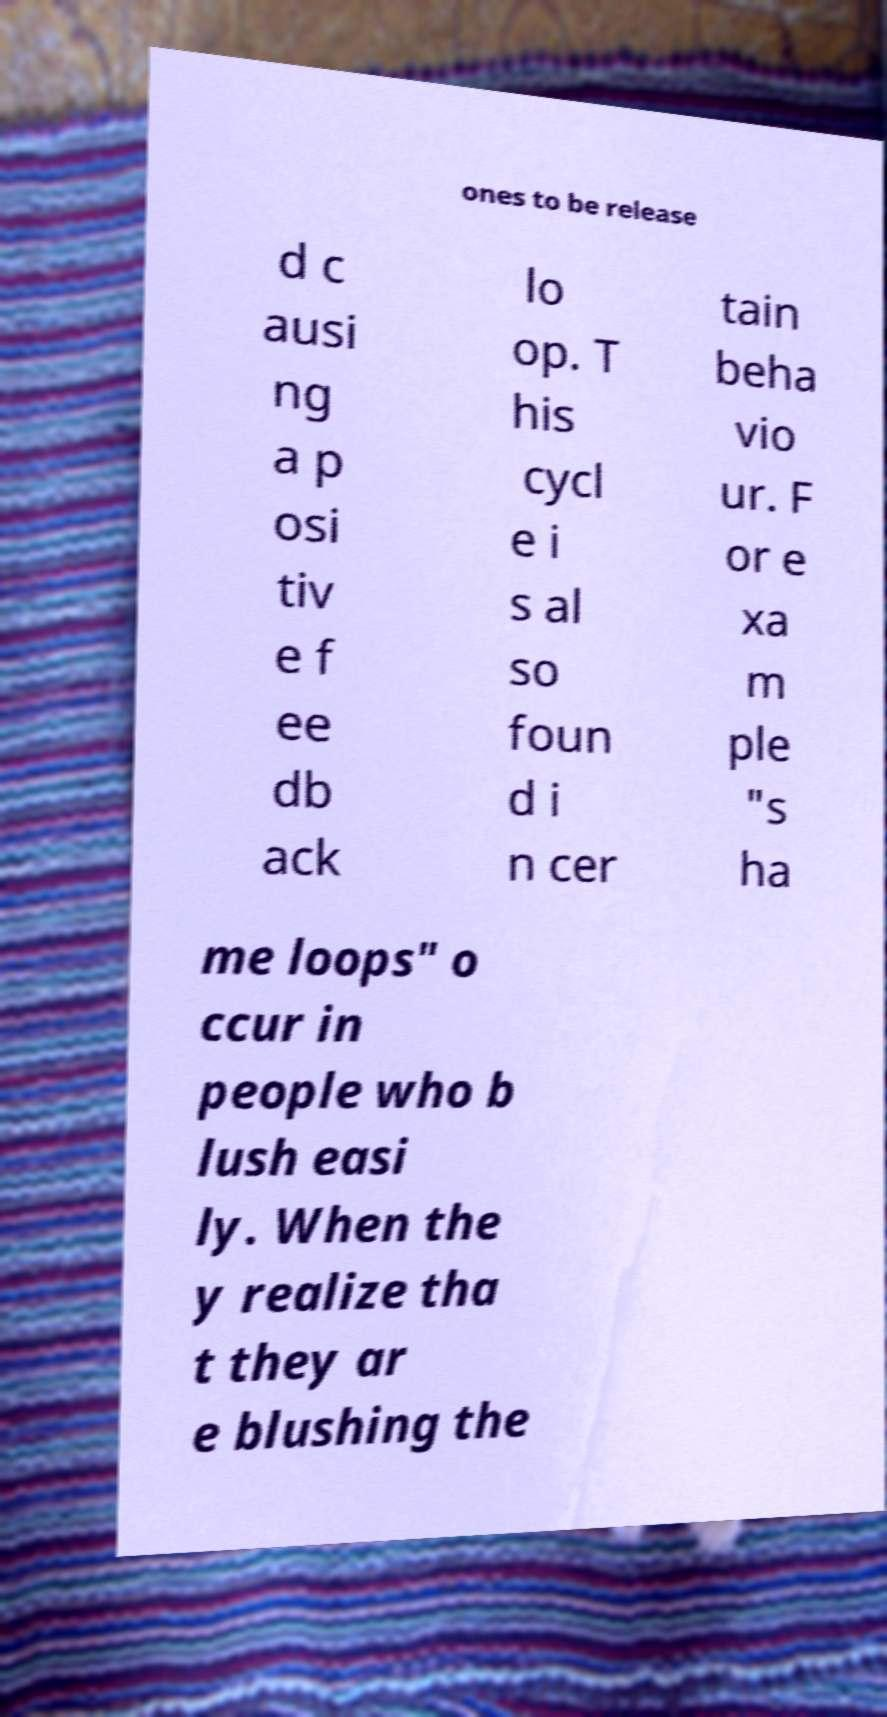What messages or text are displayed in this image? I need them in a readable, typed format. ones to be release d c ausi ng a p osi tiv e f ee db ack lo op. T his cycl e i s al so foun d i n cer tain beha vio ur. F or e xa m ple "s ha me loops" o ccur in people who b lush easi ly. When the y realize tha t they ar e blushing the 